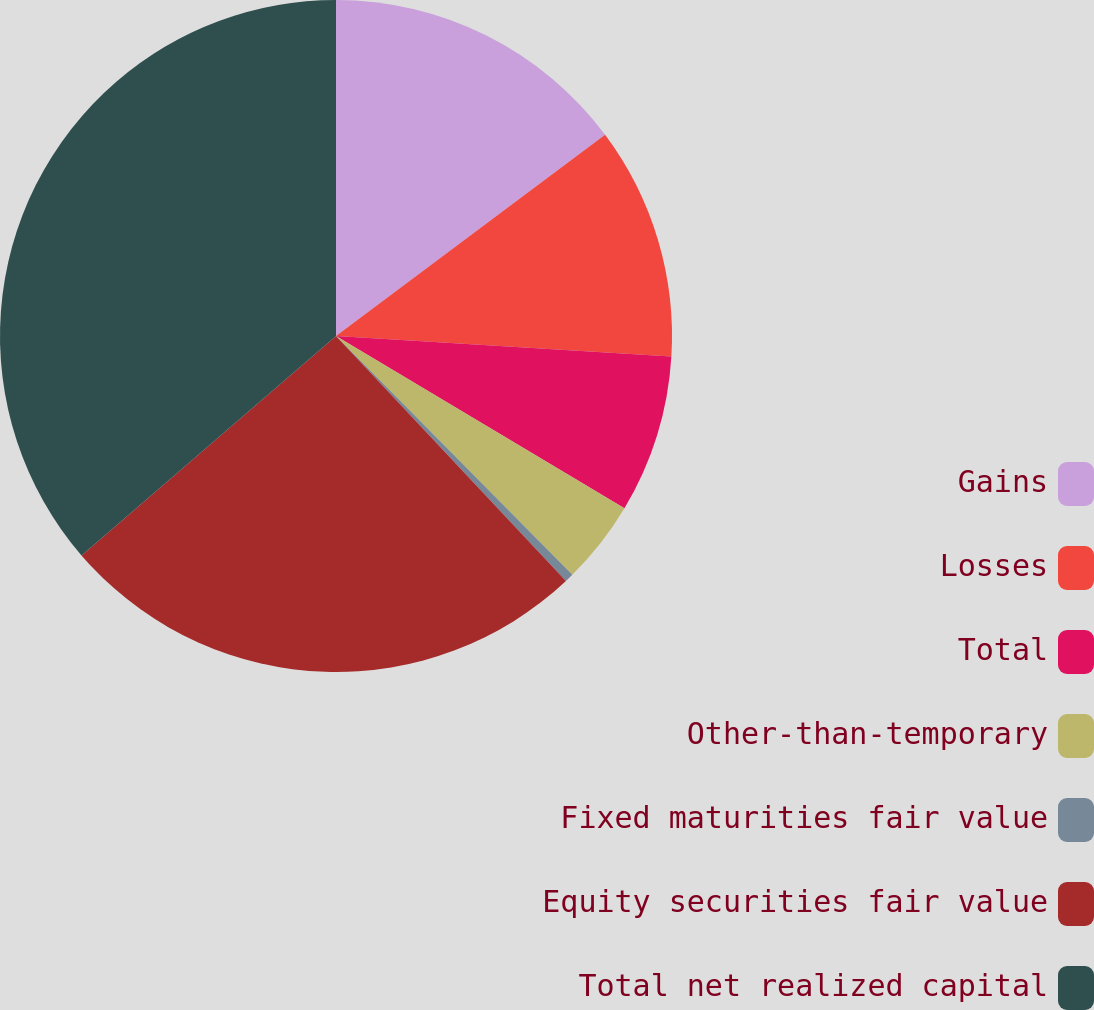<chart> <loc_0><loc_0><loc_500><loc_500><pie_chart><fcel>Gains<fcel>Losses<fcel>Total<fcel>Other-than-temporary<fcel>Fixed maturities fair value<fcel>Equity securities fair value<fcel>Total net realized capital<nl><fcel>14.78%<fcel>11.19%<fcel>7.6%<fcel>4.01%<fcel>0.42%<fcel>25.67%<fcel>36.32%<nl></chart> 